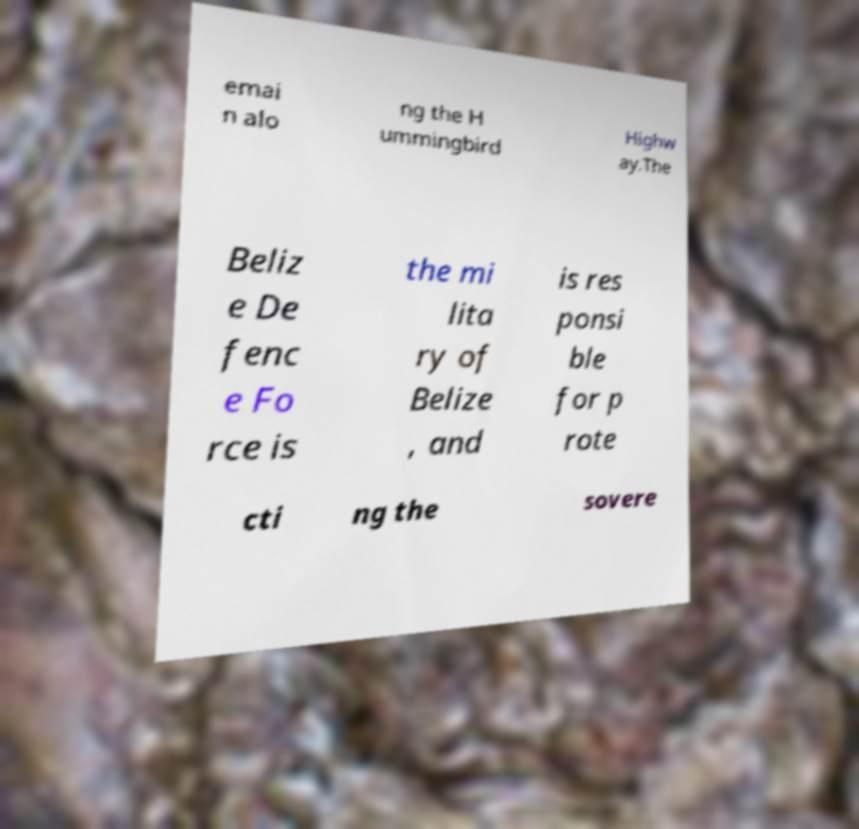Please read and relay the text visible in this image. What does it say? emai n alo ng the H ummingbird Highw ay.The Beliz e De fenc e Fo rce is the mi lita ry of Belize , and is res ponsi ble for p rote cti ng the sovere 